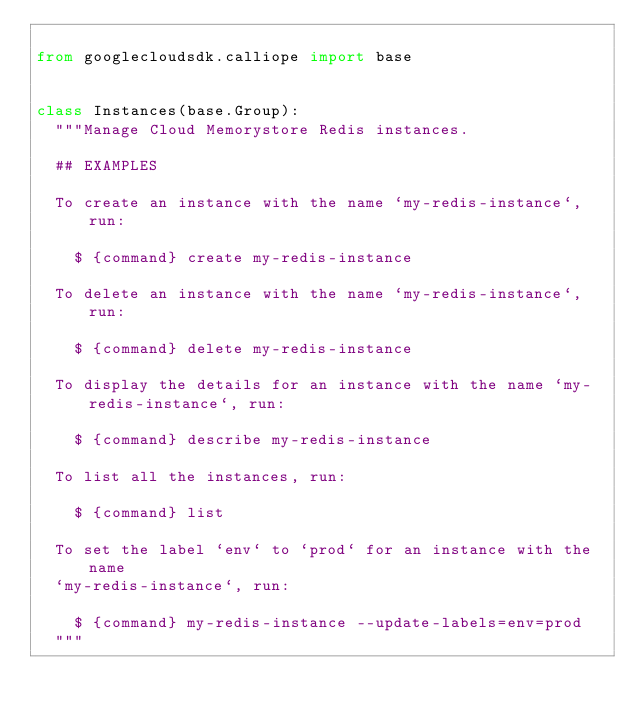<code> <loc_0><loc_0><loc_500><loc_500><_Python_>
from googlecloudsdk.calliope import base


class Instances(base.Group):
  """Manage Cloud Memorystore Redis instances.

  ## EXAMPLES

  To create an instance with the name `my-redis-instance`, run:

    $ {command} create my-redis-instance

  To delete an instance with the name `my-redis-instance`, run:

    $ {command} delete my-redis-instance

  To display the details for an instance with the name `my-redis-instance`, run:

    $ {command} describe my-redis-instance

  To list all the instances, run:

    $ {command} list

  To set the label `env` to `prod` for an instance with the name
  `my-redis-instance`, run:

    $ {command} my-redis-instance --update-labels=env=prod
  """
</code> 